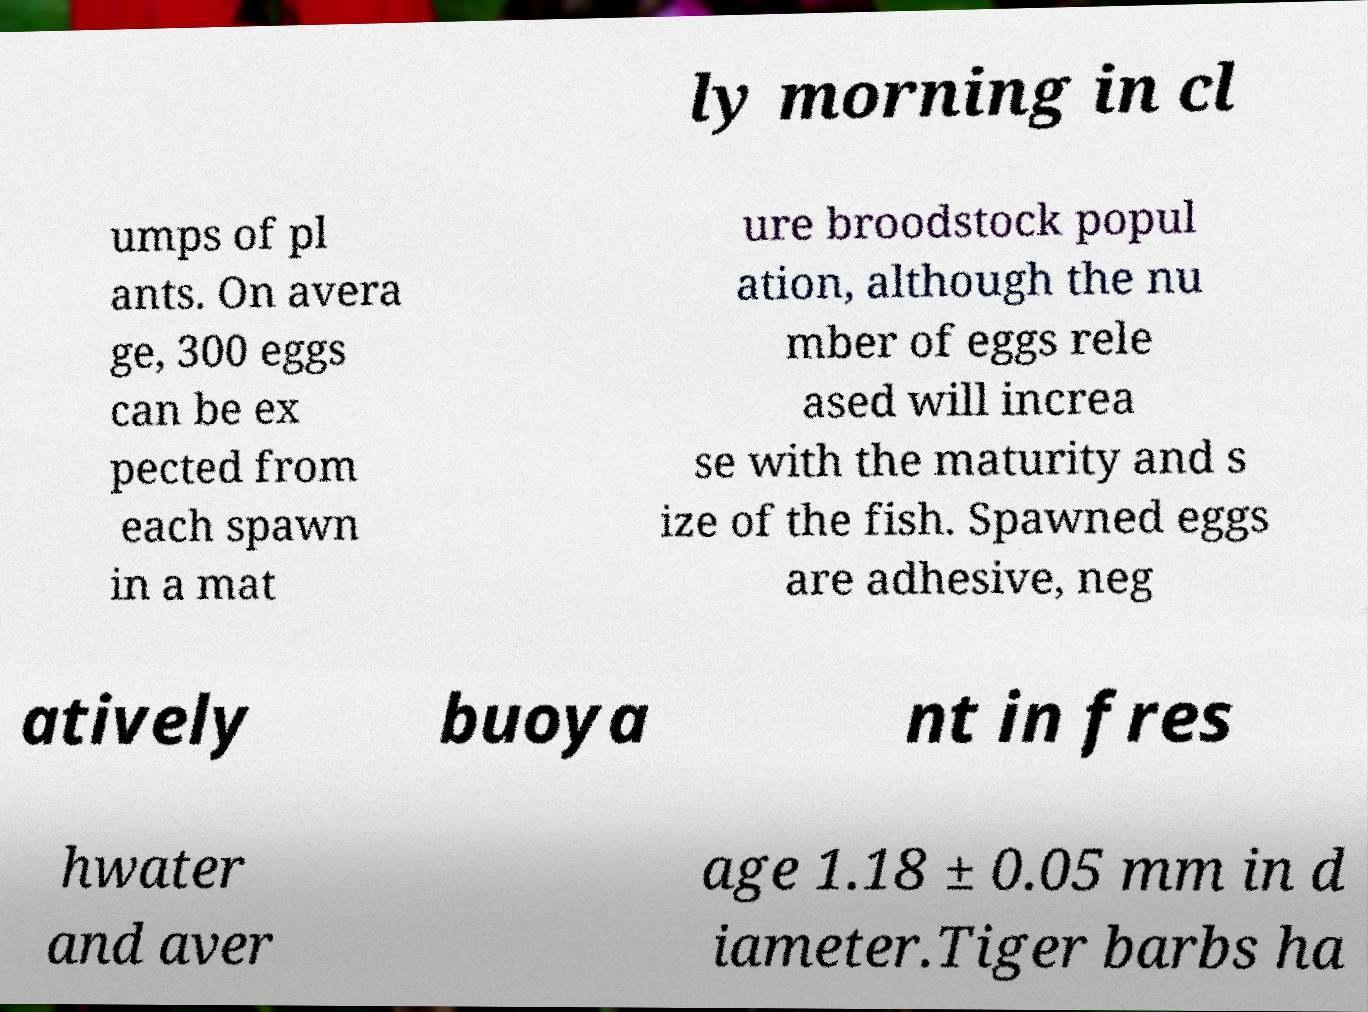Could you extract and type out the text from this image? ly morning in cl umps of pl ants. On avera ge, 300 eggs can be ex pected from each spawn in a mat ure broodstock popul ation, although the nu mber of eggs rele ased will increa se with the maturity and s ize of the fish. Spawned eggs are adhesive, neg atively buoya nt in fres hwater and aver age 1.18 ± 0.05 mm in d iameter.Tiger barbs ha 